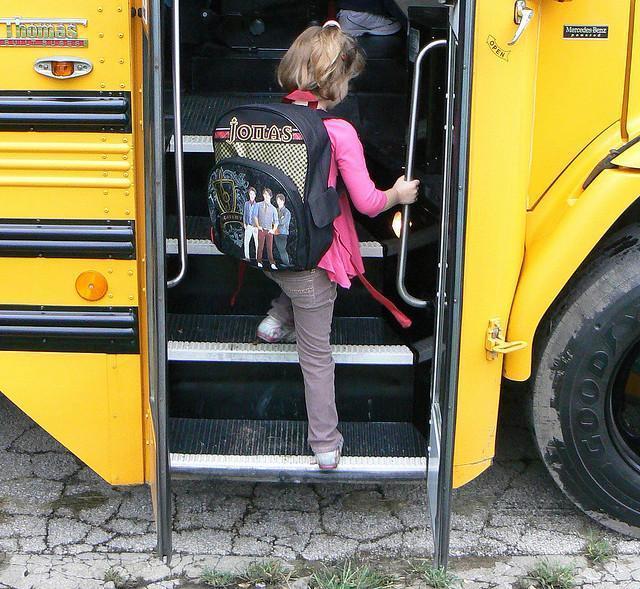How many steps are there?
Give a very brief answer. 4. How many people are in the image?
Give a very brief answer. 0. 